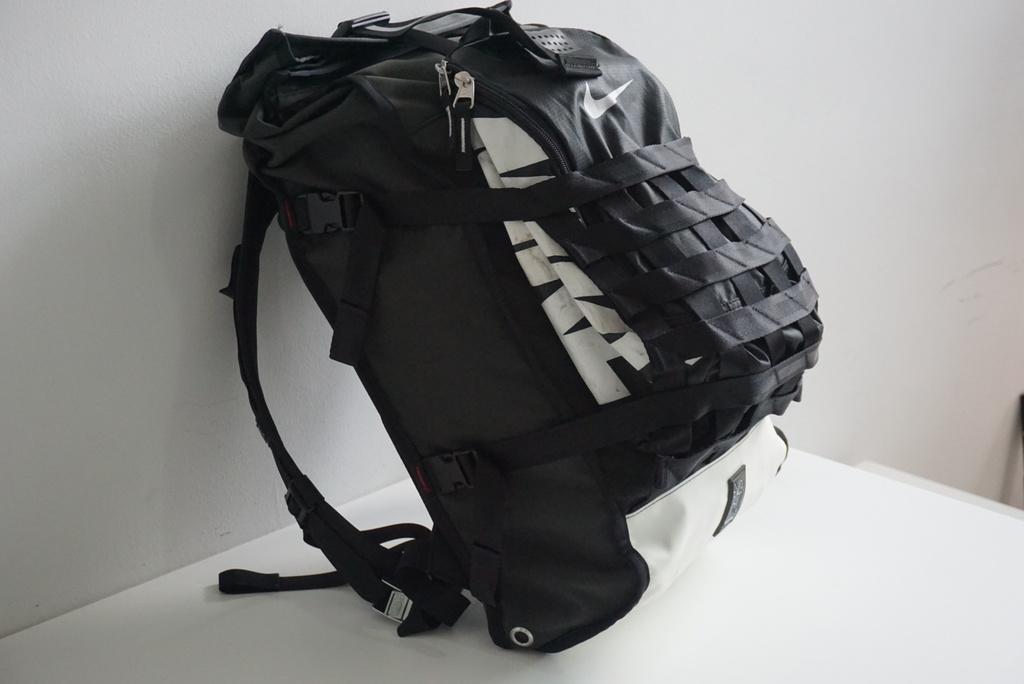Can you describe this image briefly? In the picture there is a backpack on the table. It is black in color. In the background there is wall. 